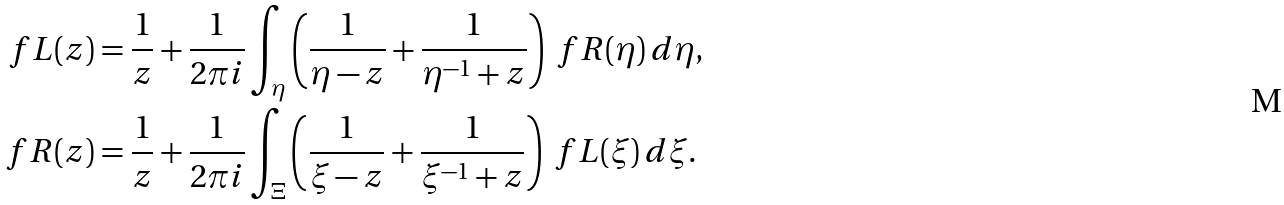<formula> <loc_0><loc_0><loc_500><loc_500>\ f L ( z ) & = \frac { 1 } { z } + \frac { 1 } { 2 \pi i } \int _ { \eta } \left ( \frac { 1 } { \eta - z } + \frac { 1 } { \eta ^ { - 1 } + z } \right ) \ f R ( \eta ) \, d \eta , \\ \ f R ( z ) & = \frac { 1 } { z } + \frac { 1 } { 2 \pi i } \int _ { \Xi } \left ( \frac { 1 } { \xi - z } + \frac { 1 } { \xi ^ { - 1 } + z } \right ) \ f L ( \xi ) \, d \xi .</formula> 